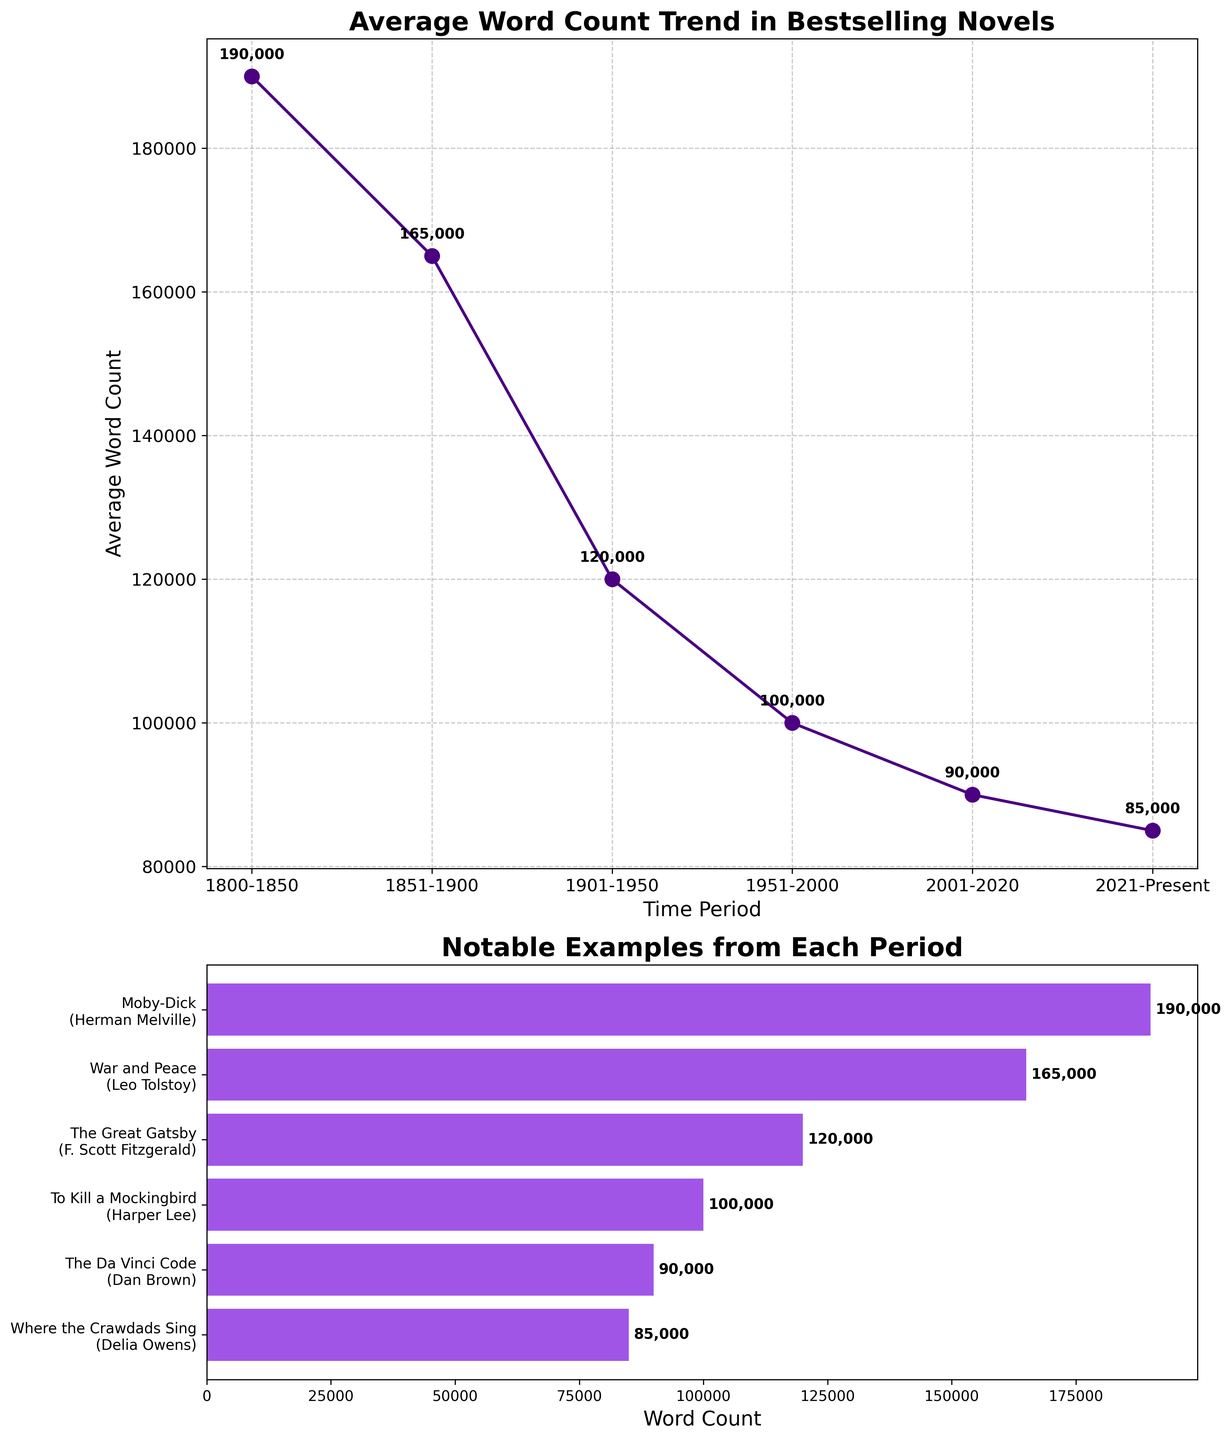What's the title of the first subplot? The title of the first subplot is provided at the top of the chart. It reads 'Average Word Count Trend in Bestselling Novels'.
Answer: Average Word Count Trend in Bestselling Novels What is the average word count for the time period 1901-1950? By looking at the first subplot, we can identify the time period 1901-1950 on the x-axis and find its corresponding point. The point is labeled with its value: '120,000'.
Answer: 120,000 How many time periods are represented in the plots? Counting the number of distinct points or bars in either the first or second subplot, we can see that there are six distinct time periods plotted.
Answer: 6 Which time period had the lowest average word count? In the first subplot, the line graph shows the point with the lowest y-value. It corresponds to the time period 2021-Present.
Answer: 2021-Present Which notable example had an average word count of 165,000? Check the second subplot where bars represent notable examples' word counts. The bar with an average word count of 165,000 is labeled with 'War and Peace' by Leo Tolstoy.
Answer: War and Peace What is the difference in average word count between the periods 1800-1850 and 2021-Present? The average word counts for 1800-1850 and 2021-Present are 190,000 and 85,000, respectively. The difference is 190,000 - 85,000 = 105,000.
Answer: 105,000 Which time period saw the greatest reduction in average word count compared to its preceding period? By checking the differences between subsequent points in the first subplot, the largest reduction occurs between 1851-1900 (165,000) and 1901-1950 (120,000), which is a reduction of 45,000.
Answer: 1851-1900 to 1901-1950 What is the average word count trend over the six time periods? The trend can be seen in the first subplot; the average word count is generally decreasing over time.
Answer: Decreasing How does the word count of 'To Kill a Mockingbird' compare with 'The Da Vinci Code'? In the second subplot, 'To Kill a Mockingbird' has a word count of 100,000 and 'The Da Vinci Code' has 90,000. 'To Kill a Mockingbird' has a higher word count by 10,000 words.
Answer: 10,000 more 